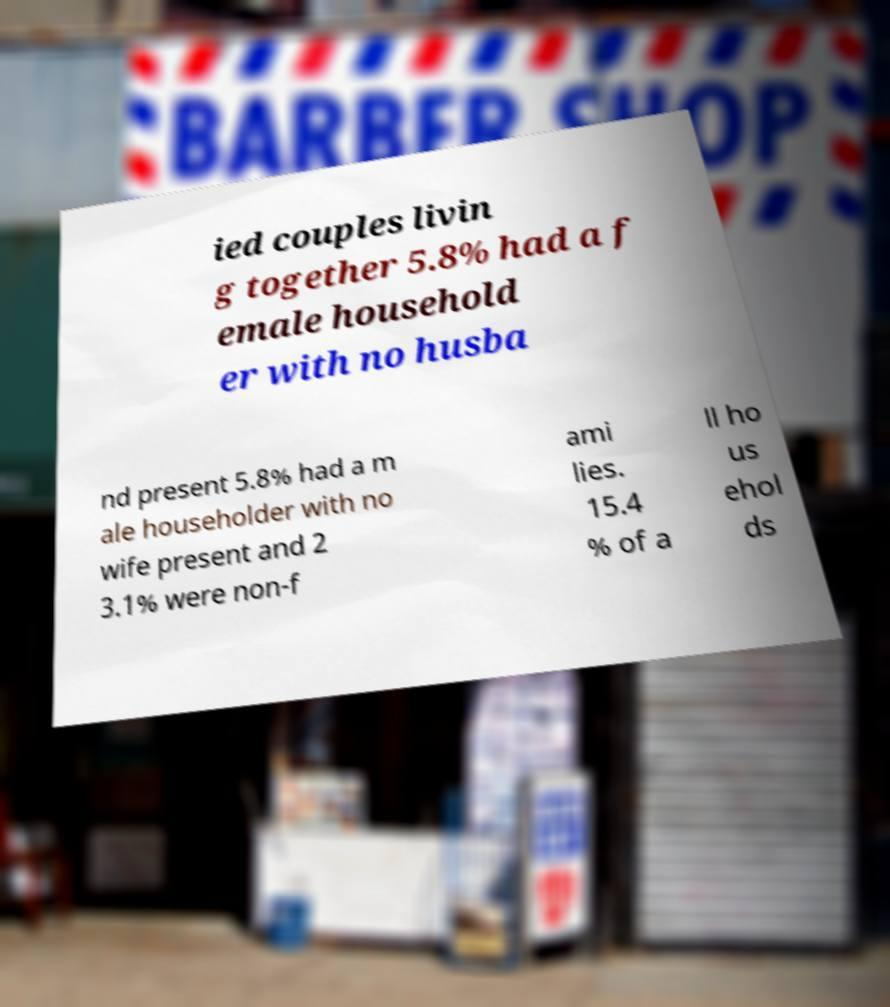Please read and relay the text visible in this image. What does it say? ied couples livin g together 5.8% had a f emale household er with no husba nd present 5.8% had a m ale householder with no wife present and 2 3.1% were non-f ami lies. 15.4 % of a ll ho us ehol ds 